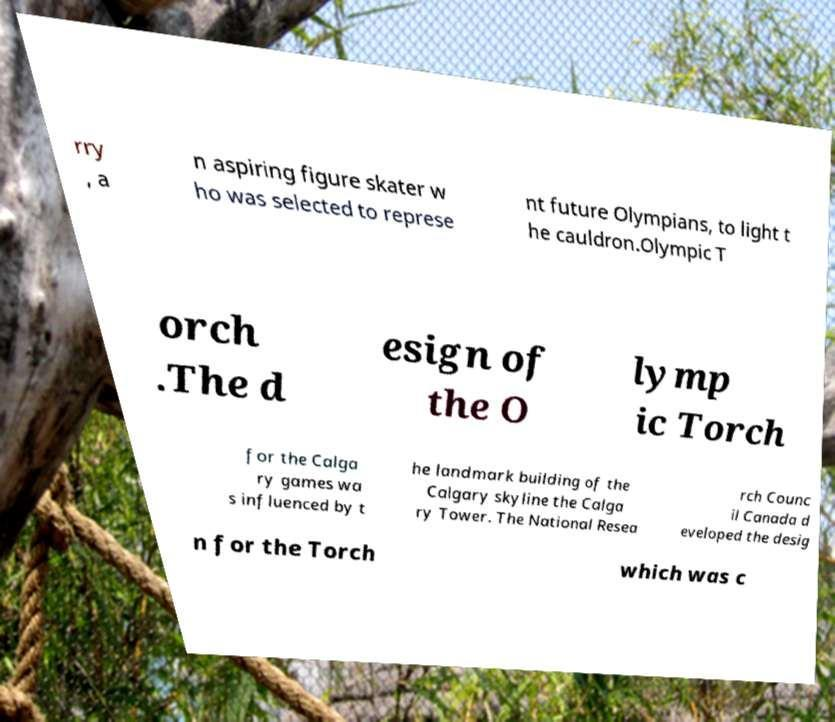Can you accurately transcribe the text from the provided image for me? rry , a n aspiring figure skater w ho was selected to represe nt future Olympians, to light t he cauldron.Olympic T orch .The d esign of the O lymp ic Torch for the Calga ry games wa s influenced by t he landmark building of the Calgary skyline the Calga ry Tower. The National Resea rch Counc il Canada d eveloped the desig n for the Torch which was c 